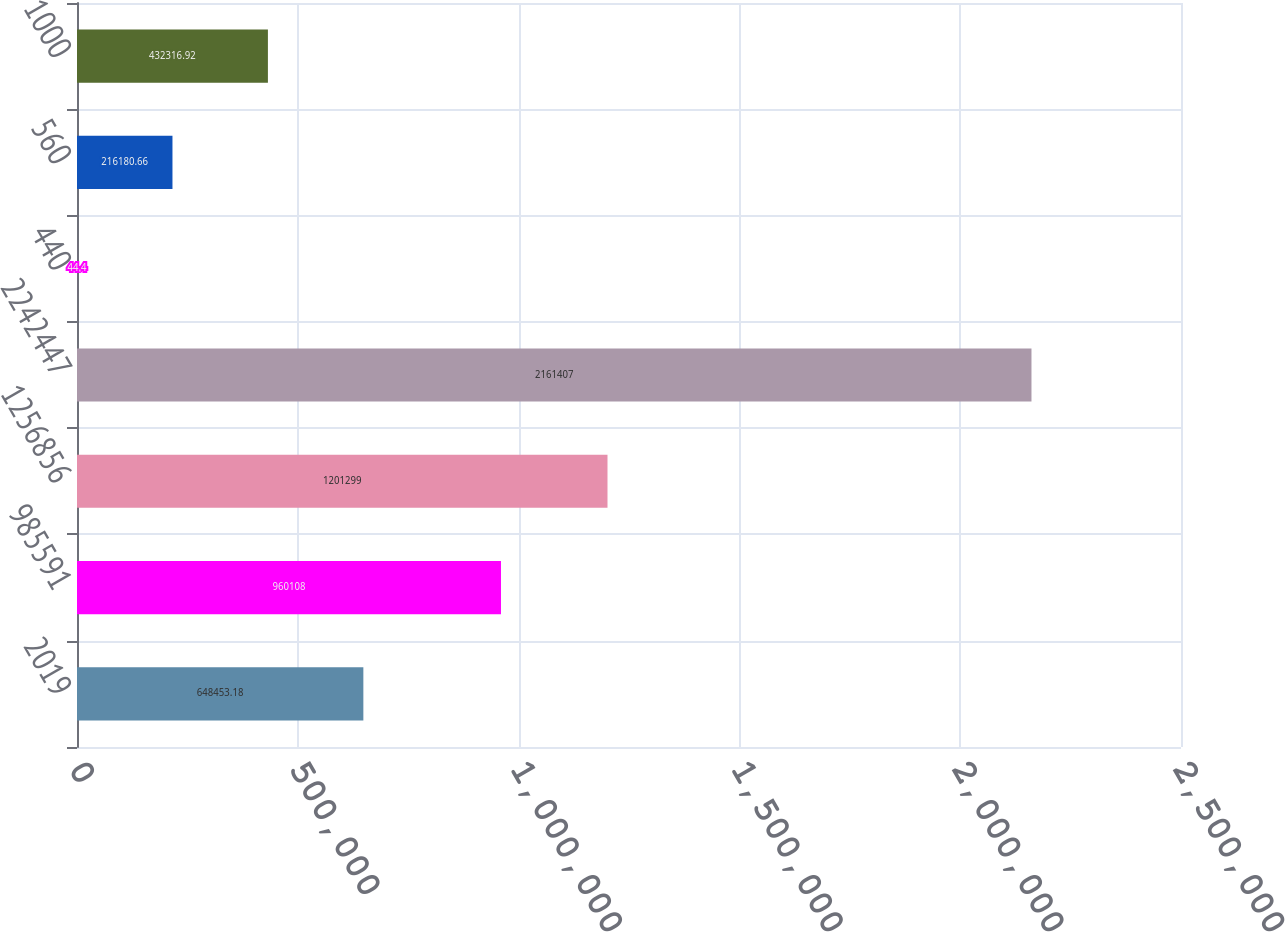<chart> <loc_0><loc_0><loc_500><loc_500><bar_chart><fcel>2019<fcel>985591<fcel>1256856<fcel>2242447<fcel>440<fcel>560<fcel>1000<nl><fcel>648453<fcel>960108<fcel>1.2013e+06<fcel>2.16141e+06<fcel>44.4<fcel>216181<fcel>432317<nl></chart> 